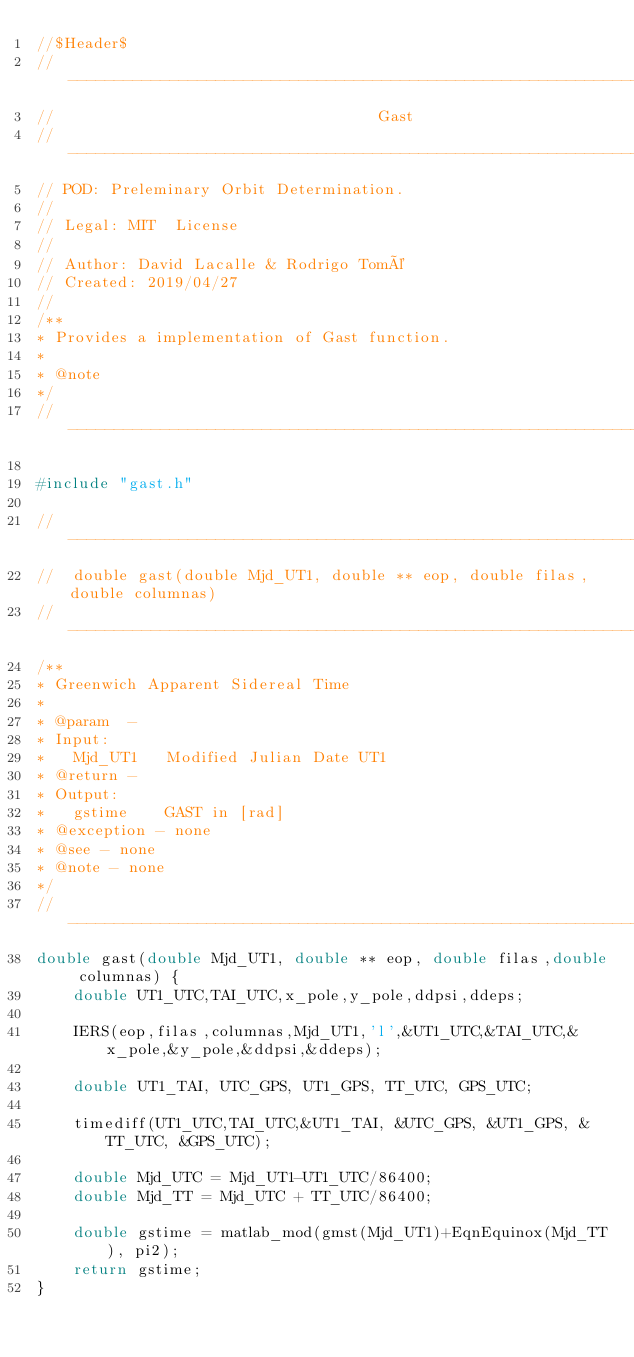<code> <loc_0><loc_0><loc_500><loc_500><_C_>//$Header$
//------------------------------------------------------------------------------
//                                   Gast
//------------------------------------------------------------------------------
// POD: Preleminary Orbit Determination.
//
// Legal: MIT  License
//
// Author: David Lacalle & Rodrigo Tomé
// Created: 2019/04/27
//
/**
* Provides a implementation of Gast function.
*
* @note
*/
//------------------------------------------------------------------------------

#include "gast.h"

//------------------------------------------------------------------------------
//  double gast(double Mjd_UT1, double ** eop, double filas,double columnas)
//------------------------------------------------------------------------------
/**
* Greenwich Apparent Sidereal Time
*
* @param  -
* Input:
*   Mjd_UT1   Modified Julian Date UT1
* @return -
* Output:
*   gstime    GAST in [rad]
* @exception - none
* @see - none
* @note - none
*/
//------------------------------------------------------------------------------
double gast(double Mjd_UT1, double ** eop, double filas,double columnas) {
    double UT1_UTC,TAI_UTC,x_pole,y_pole,ddpsi,ddeps;

    IERS(eop,filas,columnas,Mjd_UT1,'l',&UT1_UTC,&TAI_UTC,&x_pole,&y_pole,&ddpsi,&ddeps);

    double UT1_TAI, UTC_GPS, UT1_GPS, TT_UTC, GPS_UTC;

    timediff(UT1_UTC,TAI_UTC,&UT1_TAI, &UTC_GPS, &UT1_GPS, &TT_UTC, &GPS_UTC);

    double Mjd_UTC = Mjd_UT1-UT1_UTC/86400;
    double Mjd_TT = Mjd_UTC + TT_UTC/86400;

    double gstime = matlab_mod(gmst(Mjd_UT1)+EqnEquinox(Mjd_TT), pi2);
    return gstime;
}</code> 